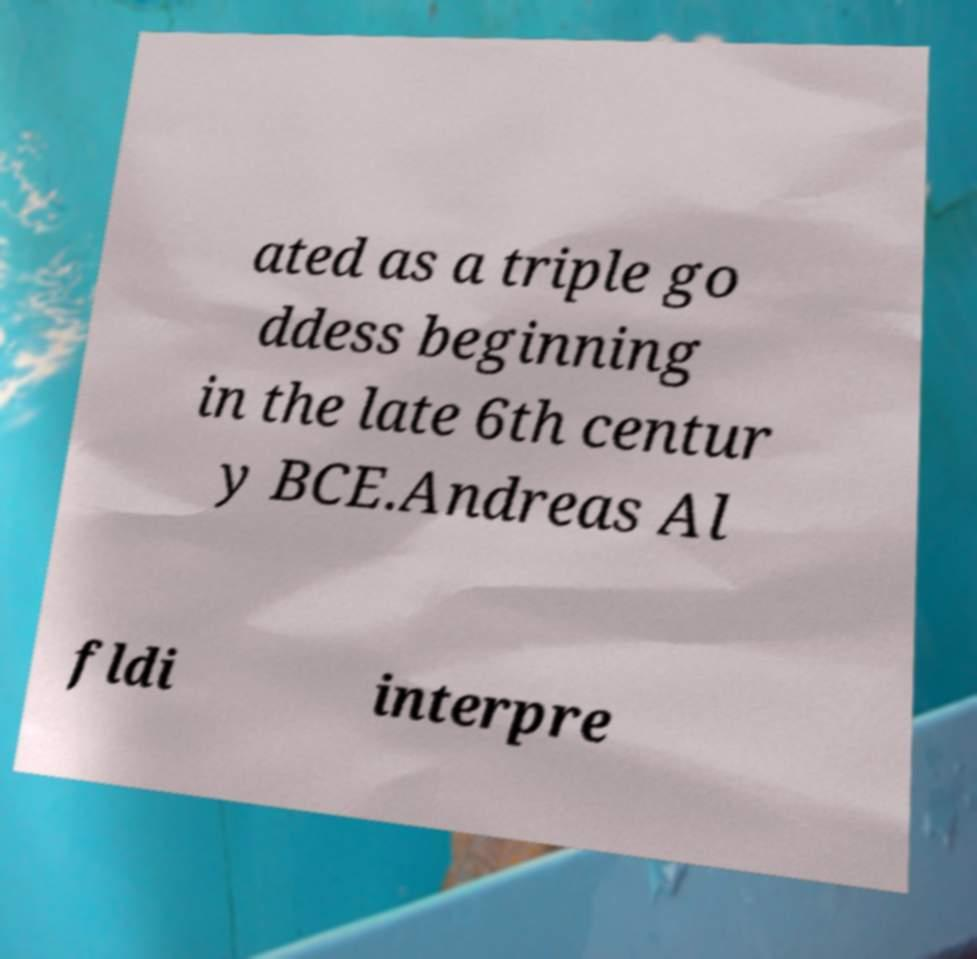Please identify and transcribe the text found in this image. ated as a triple go ddess beginning in the late 6th centur y BCE.Andreas Al fldi interpre 